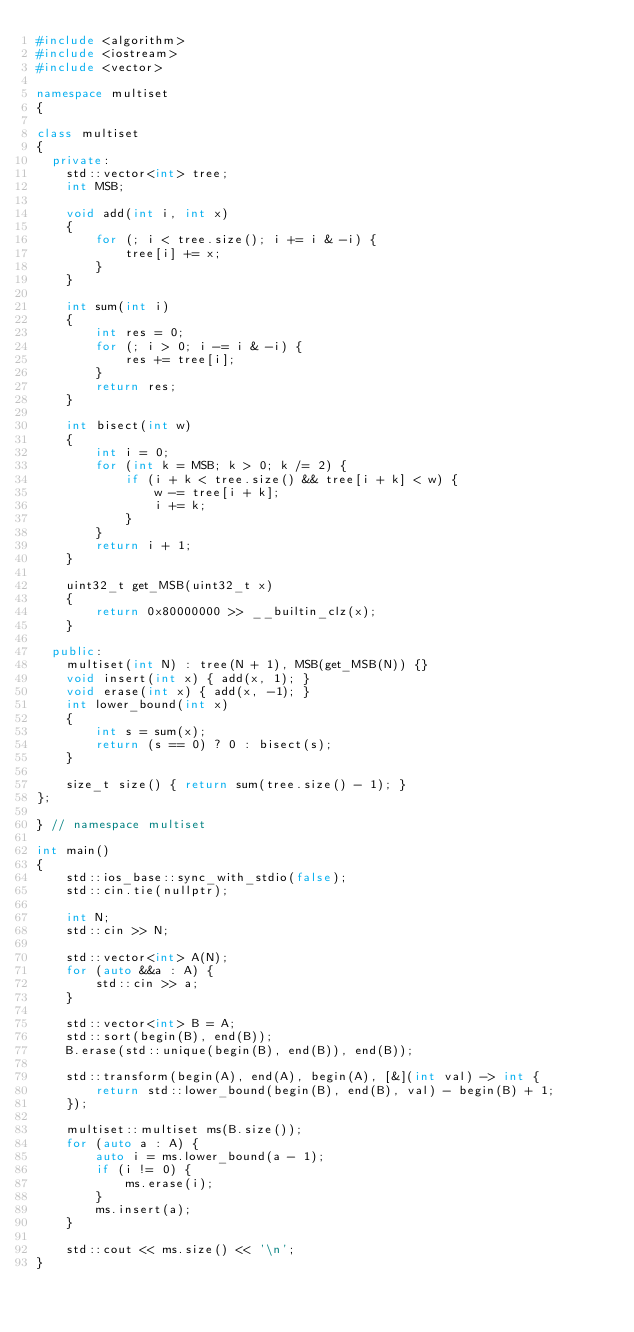<code> <loc_0><loc_0><loc_500><loc_500><_C++_>#include <algorithm>
#include <iostream>
#include <vector>

namespace multiset
{

class multiset
{
  private:
    std::vector<int> tree;
    int MSB;

    void add(int i, int x)
    {
        for (; i < tree.size(); i += i & -i) {
            tree[i] += x;
        }
    }

    int sum(int i)
    {
        int res = 0;
        for (; i > 0; i -= i & -i) {
            res += tree[i];
        }
        return res;
    }

    int bisect(int w)
    {
        int i = 0;
        for (int k = MSB; k > 0; k /= 2) {
            if (i + k < tree.size() && tree[i + k] < w) {
                w -= tree[i + k];
                i += k;
            }
        }
        return i + 1;
    }

    uint32_t get_MSB(uint32_t x)
    {
        return 0x80000000 >> __builtin_clz(x);
    }

  public:
    multiset(int N) : tree(N + 1), MSB(get_MSB(N)) {}
    void insert(int x) { add(x, 1); }
    void erase(int x) { add(x, -1); }
    int lower_bound(int x)
    {
        int s = sum(x);
        return (s == 0) ? 0 : bisect(s);
    }

    size_t size() { return sum(tree.size() - 1); }
};

} // namespace multiset

int main()
{
    std::ios_base::sync_with_stdio(false);
    std::cin.tie(nullptr);

    int N;
    std::cin >> N;

    std::vector<int> A(N);
    for (auto &&a : A) {
        std::cin >> a;
    }

    std::vector<int> B = A;
    std::sort(begin(B), end(B));
    B.erase(std::unique(begin(B), end(B)), end(B));

    std::transform(begin(A), end(A), begin(A), [&](int val) -> int {
        return std::lower_bound(begin(B), end(B), val) - begin(B) + 1;
    });

    multiset::multiset ms(B.size());
    for (auto a : A) {
        auto i = ms.lower_bound(a - 1);
        if (i != 0) {
            ms.erase(i);
        }
        ms.insert(a);
    }

    std::cout << ms.size() << '\n';
}
</code> 